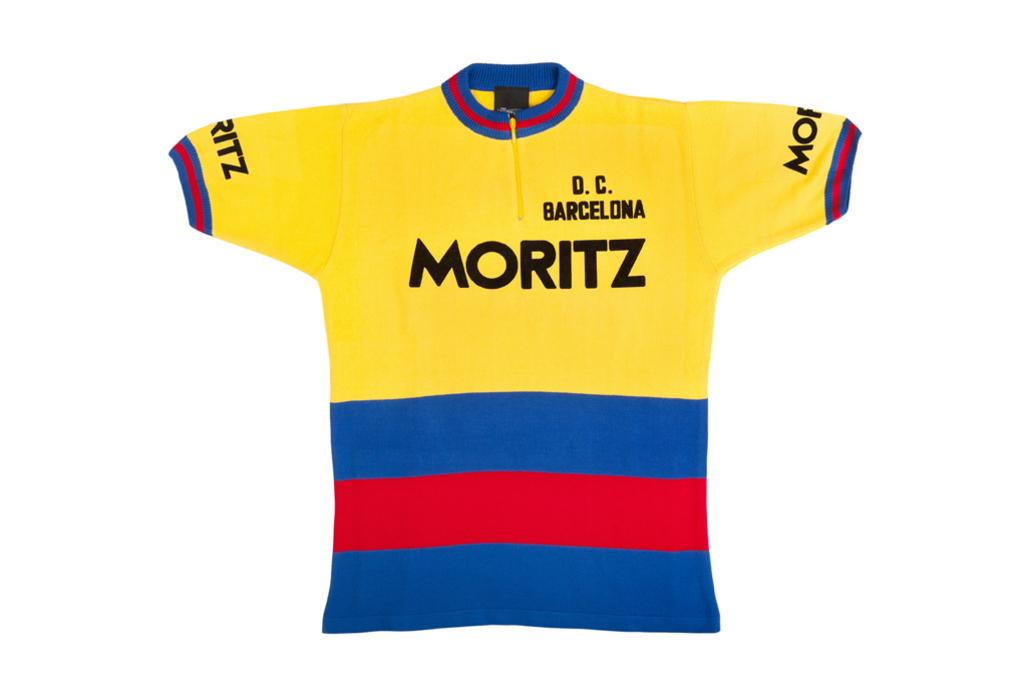<image>
Summarize the visual content of the image. a jersey that has Moritz on the front 